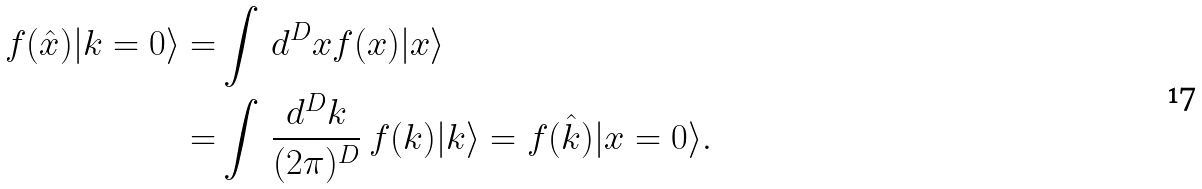<formula> <loc_0><loc_0><loc_500><loc_500>f ( \hat { x } ) | k = 0 \rangle = & \int \, d ^ { D } x f ( x ) | x \rangle \\ = & \int \, \frac { d ^ { D } k } { ( 2 \pi ) ^ { D } } \ f ( k ) | k \rangle = f ( \hat { k } ) | x = 0 \rangle .</formula> 